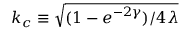<formula> <loc_0><loc_0><loc_500><loc_500>k _ { c } \equiv \sqrt { { ( 1 - e ^ { - 2 \gamma } ) } / { 4 \lambda } }</formula> 